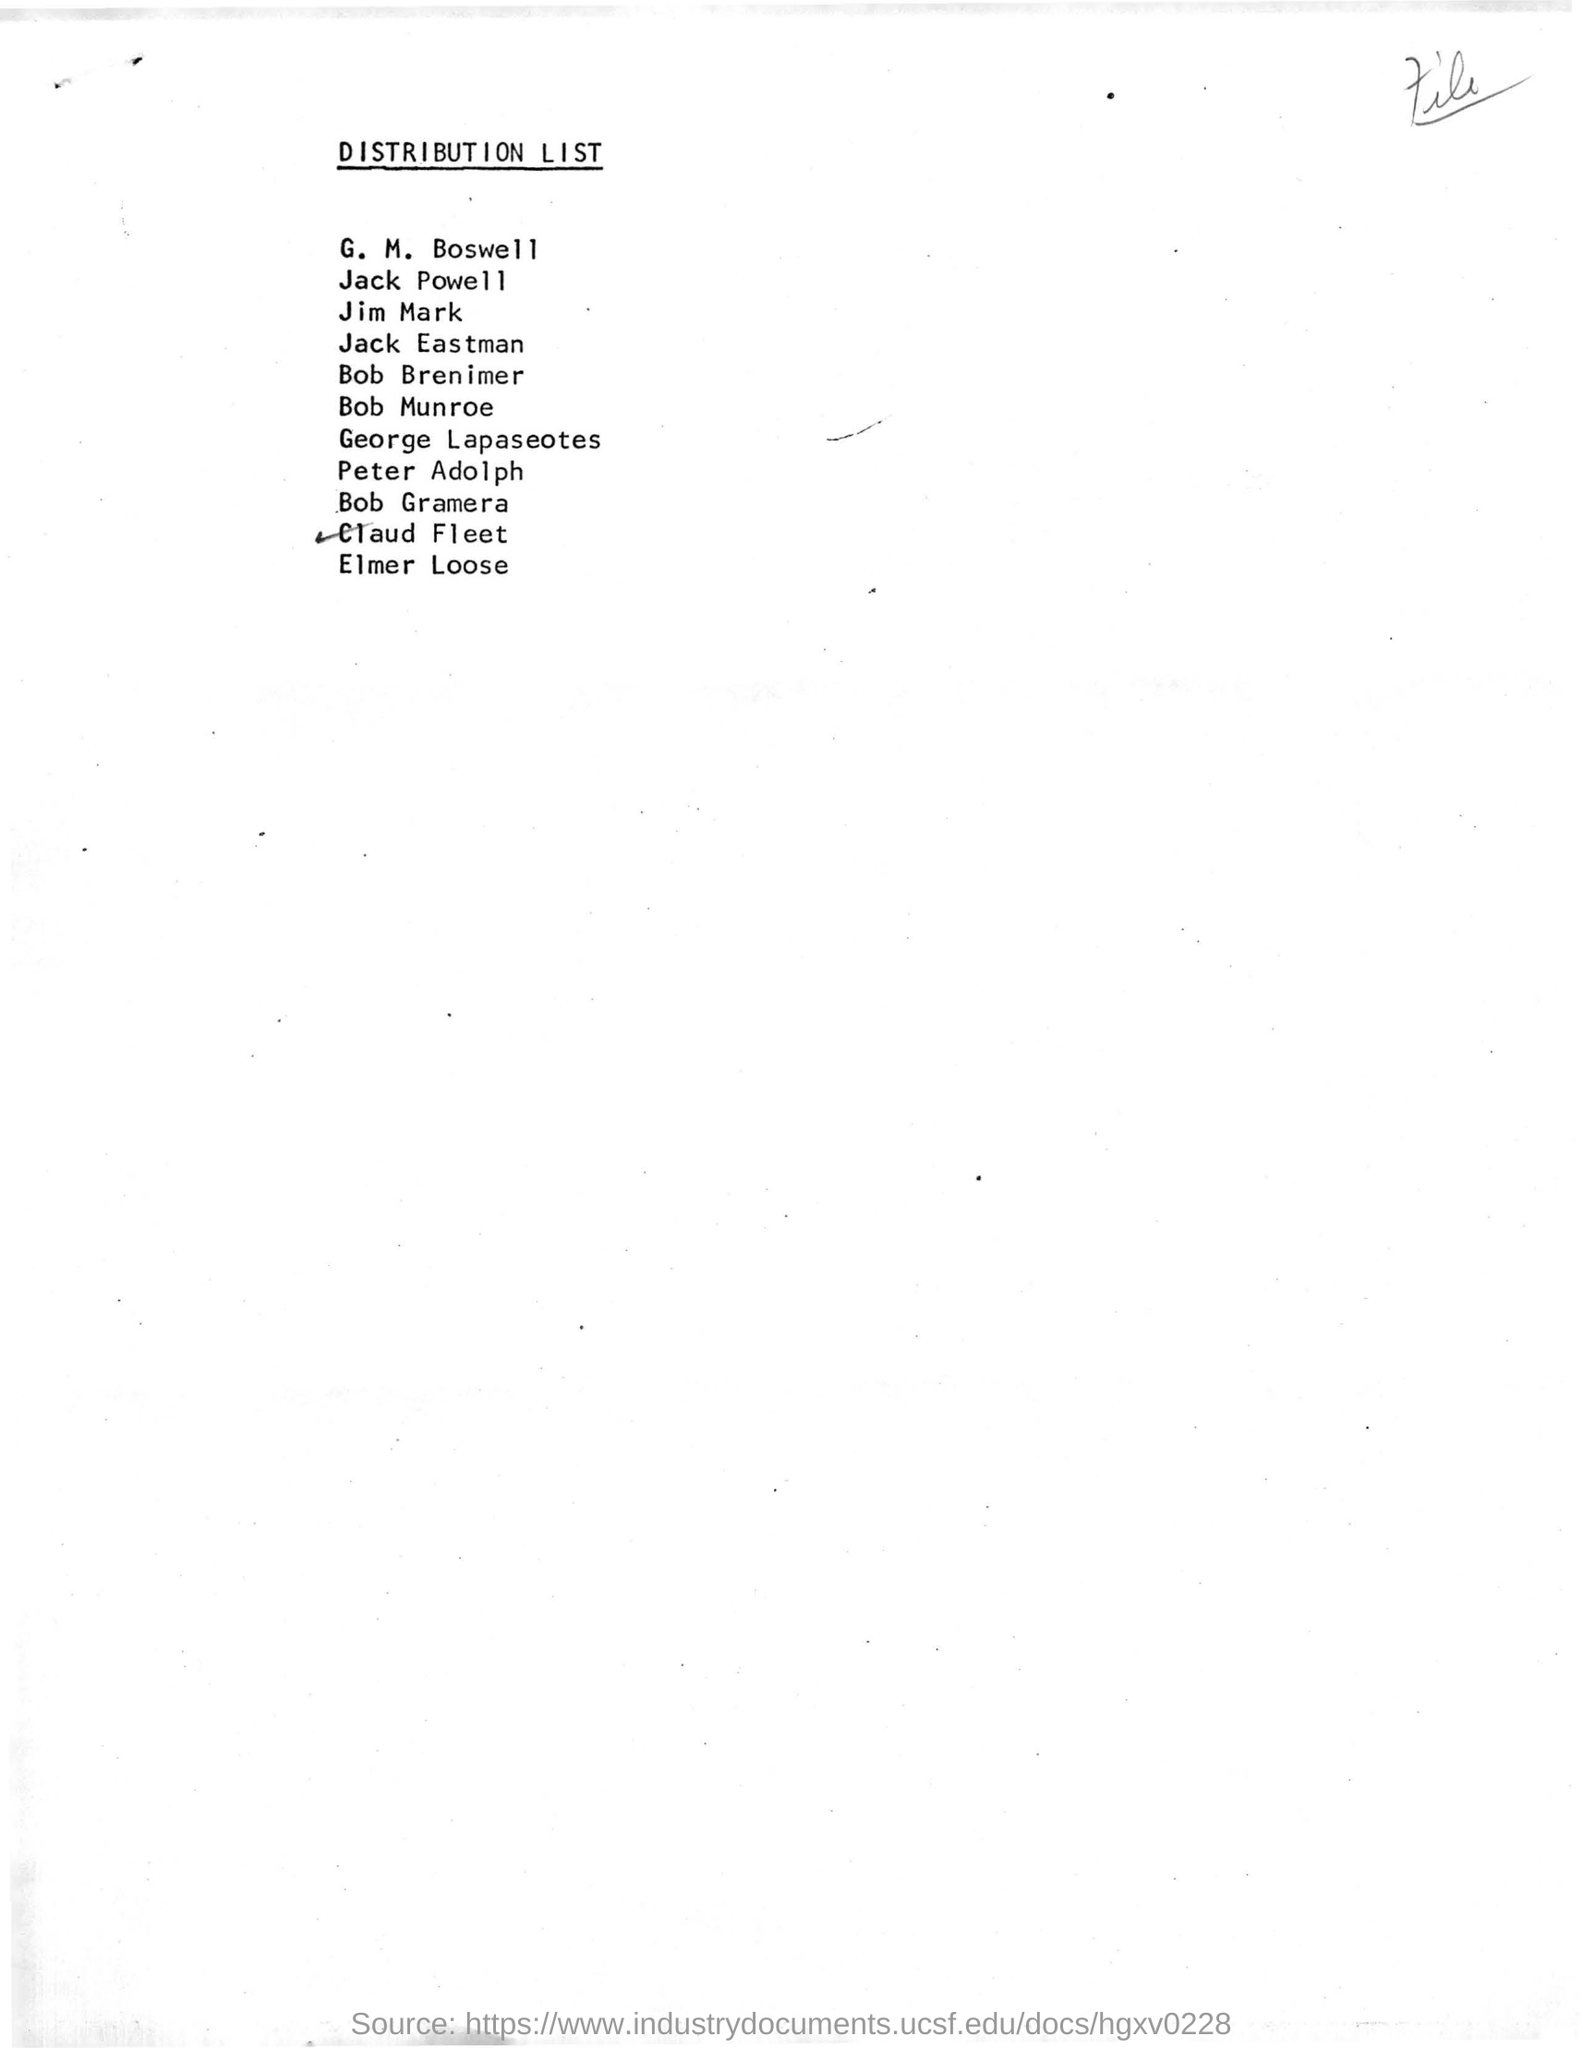What is the title of the document?
Your answer should be compact. DISTRIBUTION LIST. What is the first name given in the distribution list?
Keep it short and to the point. G. M. Boswell. 